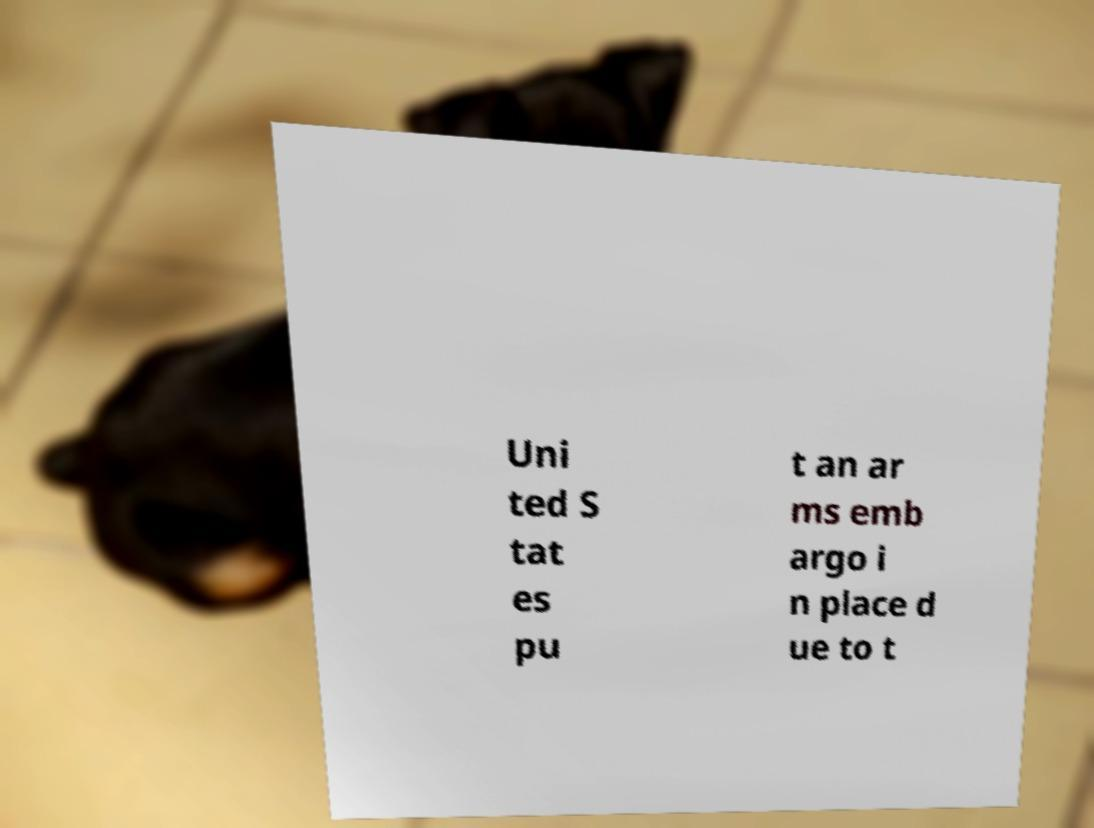Please read and relay the text visible in this image. What does it say? Uni ted S tat es pu t an ar ms emb argo i n place d ue to t 